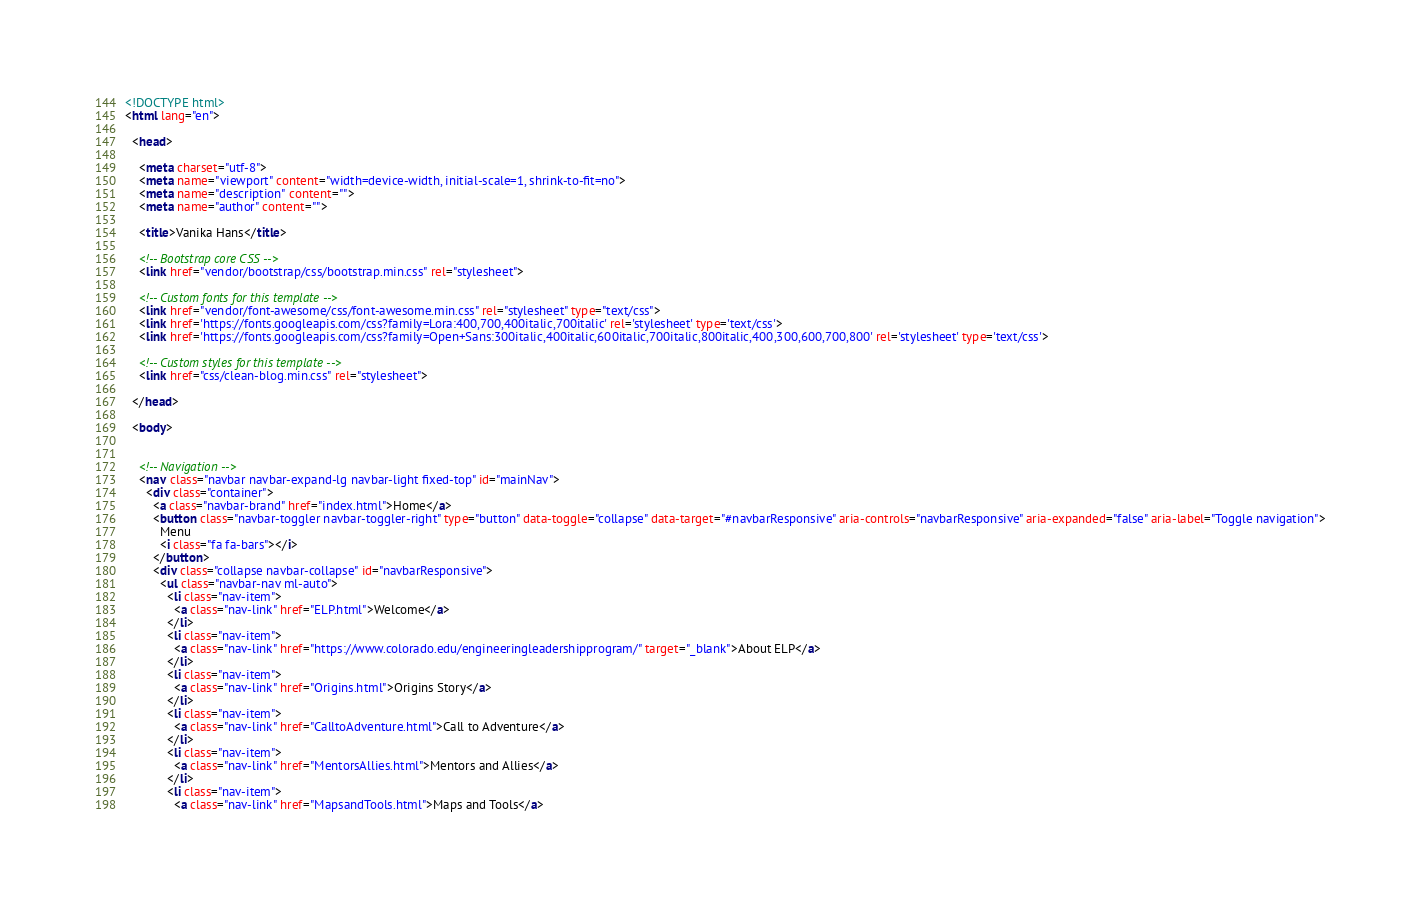Convert code to text. <code><loc_0><loc_0><loc_500><loc_500><_HTML_><!DOCTYPE html>
<html lang="en">

  <head>

    <meta charset="utf-8">
    <meta name="viewport" content="width=device-width, initial-scale=1, shrink-to-fit=no">
    <meta name="description" content="">
    <meta name="author" content="">

    <title>Vanika Hans</title>

    <!-- Bootstrap core CSS -->
    <link href="vendor/bootstrap/css/bootstrap.min.css" rel="stylesheet">

    <!-- Custom fonts for this template -->
    <link href="vendor/font-awesome/css/font-awesome.min.css" rel="stylesheet" type="text/css">
    <link href='https://fonts.googleapis.com/css?family=Lora:400,700,400italic,700italic' rel='stylesheet' type='text/css'>
    <link href='https://fonts.googleapis.com/css?family=Open+Sans:300italic,400italic,600italic,700italic,800italic,400,300,600,700,800' rel='stylesheet' type='text/css'>

    <!-- Custom styles for this template -->
    <link href="css/clean-blog.min.css" rel="stylesheet">

  </head>

  <body>


    <!-- Navigation -->
    <nav class="navbar navbar-expand-lg navbar-light fixed-top" id="mainNav">
      <div class="container">
        <a class="navbar-brand" href="index.html">Home</a>
        <button class="navbar-toggler navbar-toggler-right" type="button" data-toggle="collapse" data-target="#navbarResponsive" aria-controls="navbarResponsive" aria-expanded="false" aria-label="Toggle navigation">
          Menu
          <i class="fa fa-bars"></i>
        </button>
        <div class="collapse navbar-collapse" id="navbarResponsive">
          <ul class="navbar-nav ml-auto">
            <li class="nav-item">
              <a class="nav-link" href="ELP.html">Welcome</a>
            </li>
            <li class="nav-item">
              <a class="nav-link" href="https://www.colorado.edu/engineeringleadershipprogram/" target="_blank">About ELP</a>
            </li>
            <li class="nav-item">
              <a class="nav-link" href="Origins.html">Origins Story</a>
            </li>
            <li class="nav-item">
              <a class="nav-link" href="CalltoAdventure.html">Call to Adventure</a>
            </li>
			<li class="nav-item">
              <a class="nav-link" href="MentorsAllies.html">Mentors and Allies</a>
            </li>
			<li class="nav-item">
              <a class="nav-link" href="MapsandTools.html">Maps and Tools</a></code> 